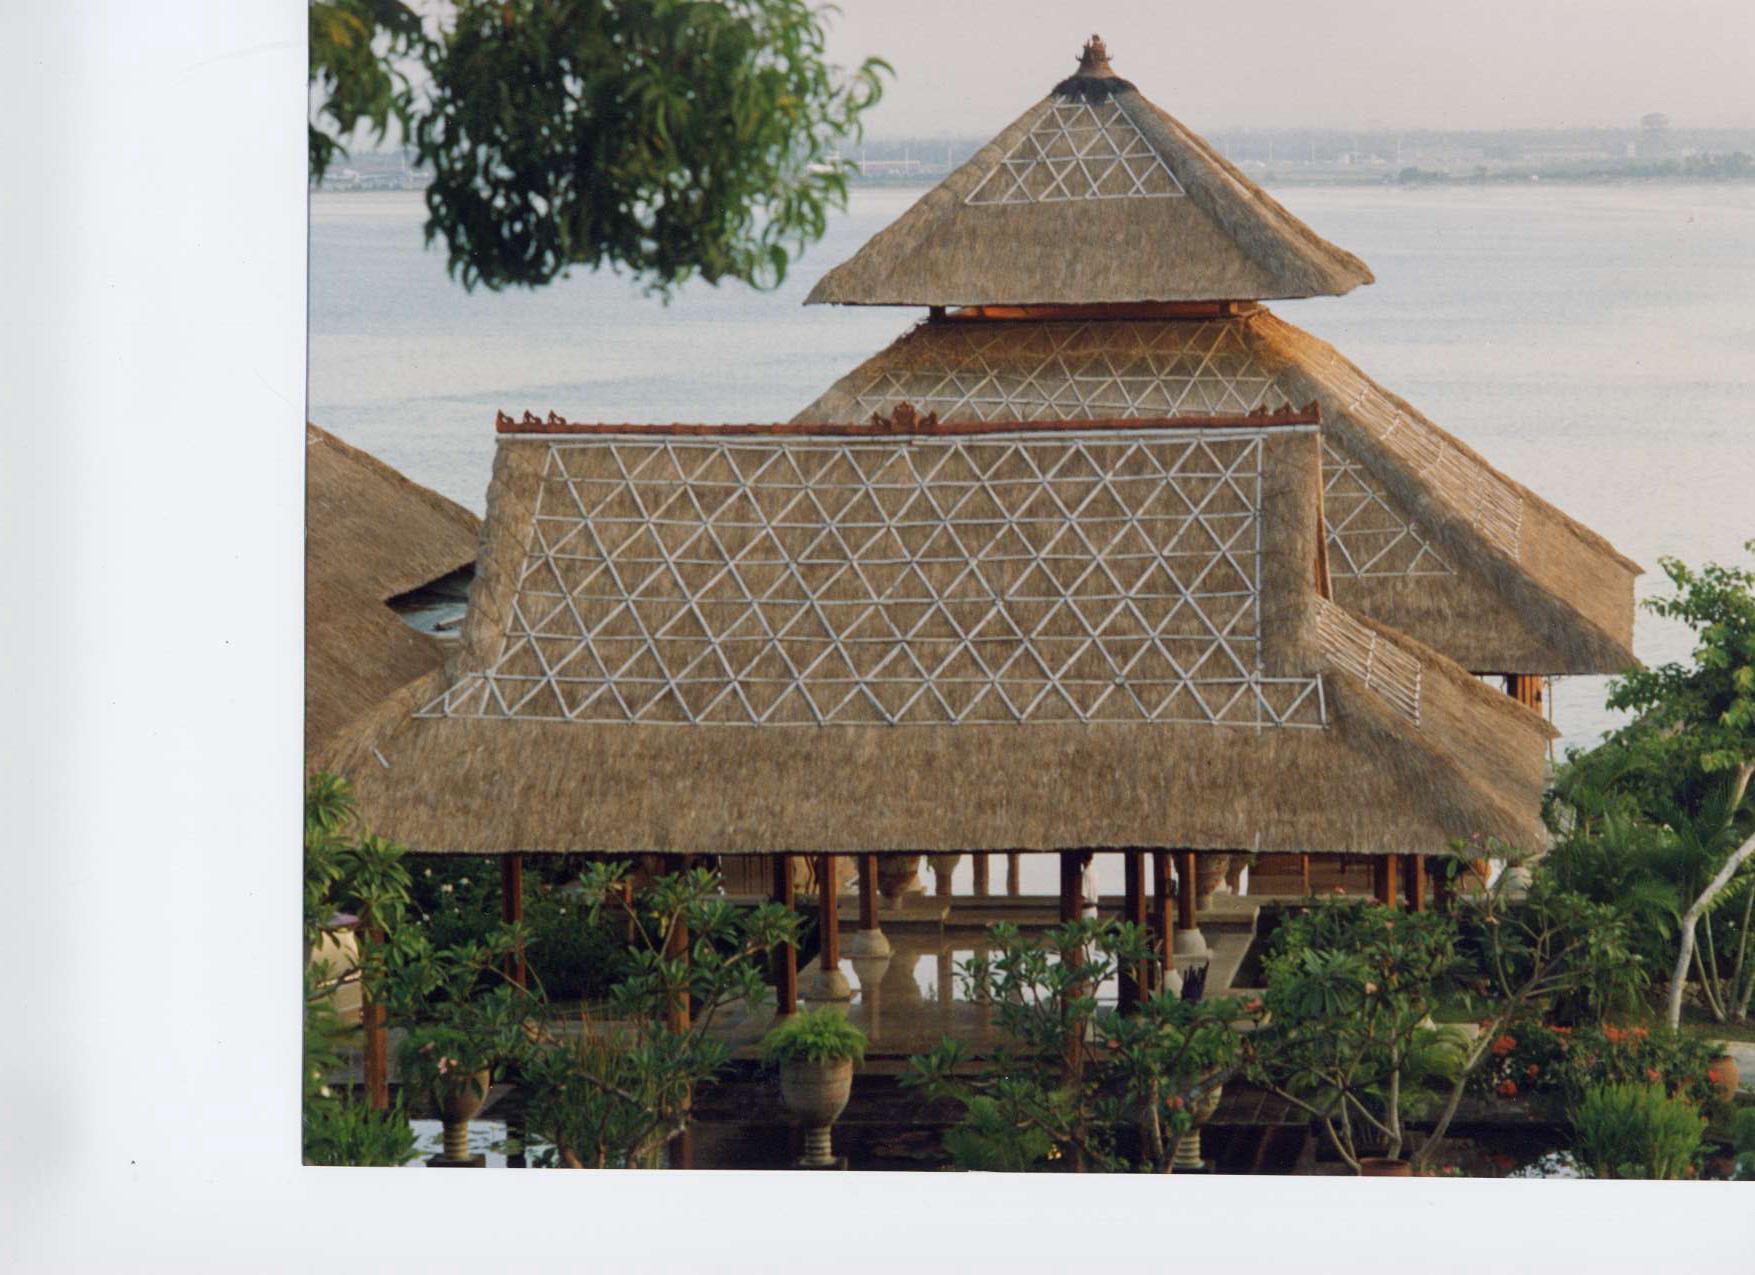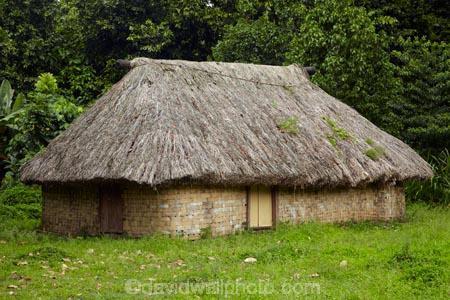The first image is the image on the left, the second image is the image on the right. For the images displayed, is the sentence "One image shows a structure with at least one peaked roof held up by beams and with open sides, in front of a body of water" factually correct? Answer yes or no. Yes. The first image is the image on the left, the second image is the image on the right. Assess this claim about the two images: "A round hut with a round grass roof can be seen.". Correct or not? Answer yes or no. No. 